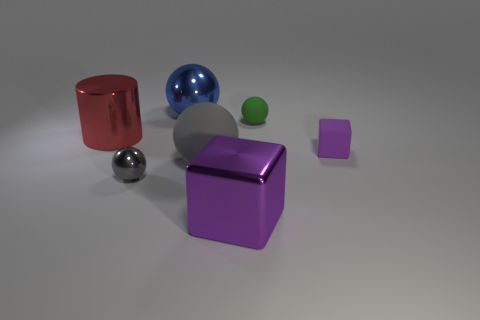Is there any other thing that is the same color as the tiny rubber block?
Your answer should be compact. Yes. Is the number of big gray matte objects left of the red shiny cylinder less than the number of big cyan rubber cylinders?
Offer a very short reply. No. How many gray rubber things have the same size as the red metallic cylinder?
Make the answer very short. 1. What shape is the thing that is the same color as the rubber cube?
Your answer should be compact. Cube. There is a purple thing right of the metallic thing that is to the right of the metallic sphere to the right of the small gray metallic sphere; what shape is it?
Offer a terse response. Cube. There is a small sphere behind the purple rubber cube; what is its color?
Ensure brevity in your answer.  Green. How many things are large metal things behind the green rubber thing or big metallic objects that are behind the green object?
Keep it short and to the point. 1. How many small objects have the same shape as the big blue object?
Your response must be concise. 2. The metal ball that is the same size as the purple shiny object is what color?
Offer a terse response. Blue. There is a small sphere right of the cube that is in front of the metal sphere in front of the big red cylinder; what color is it?
Give a very brief answer. Green. 